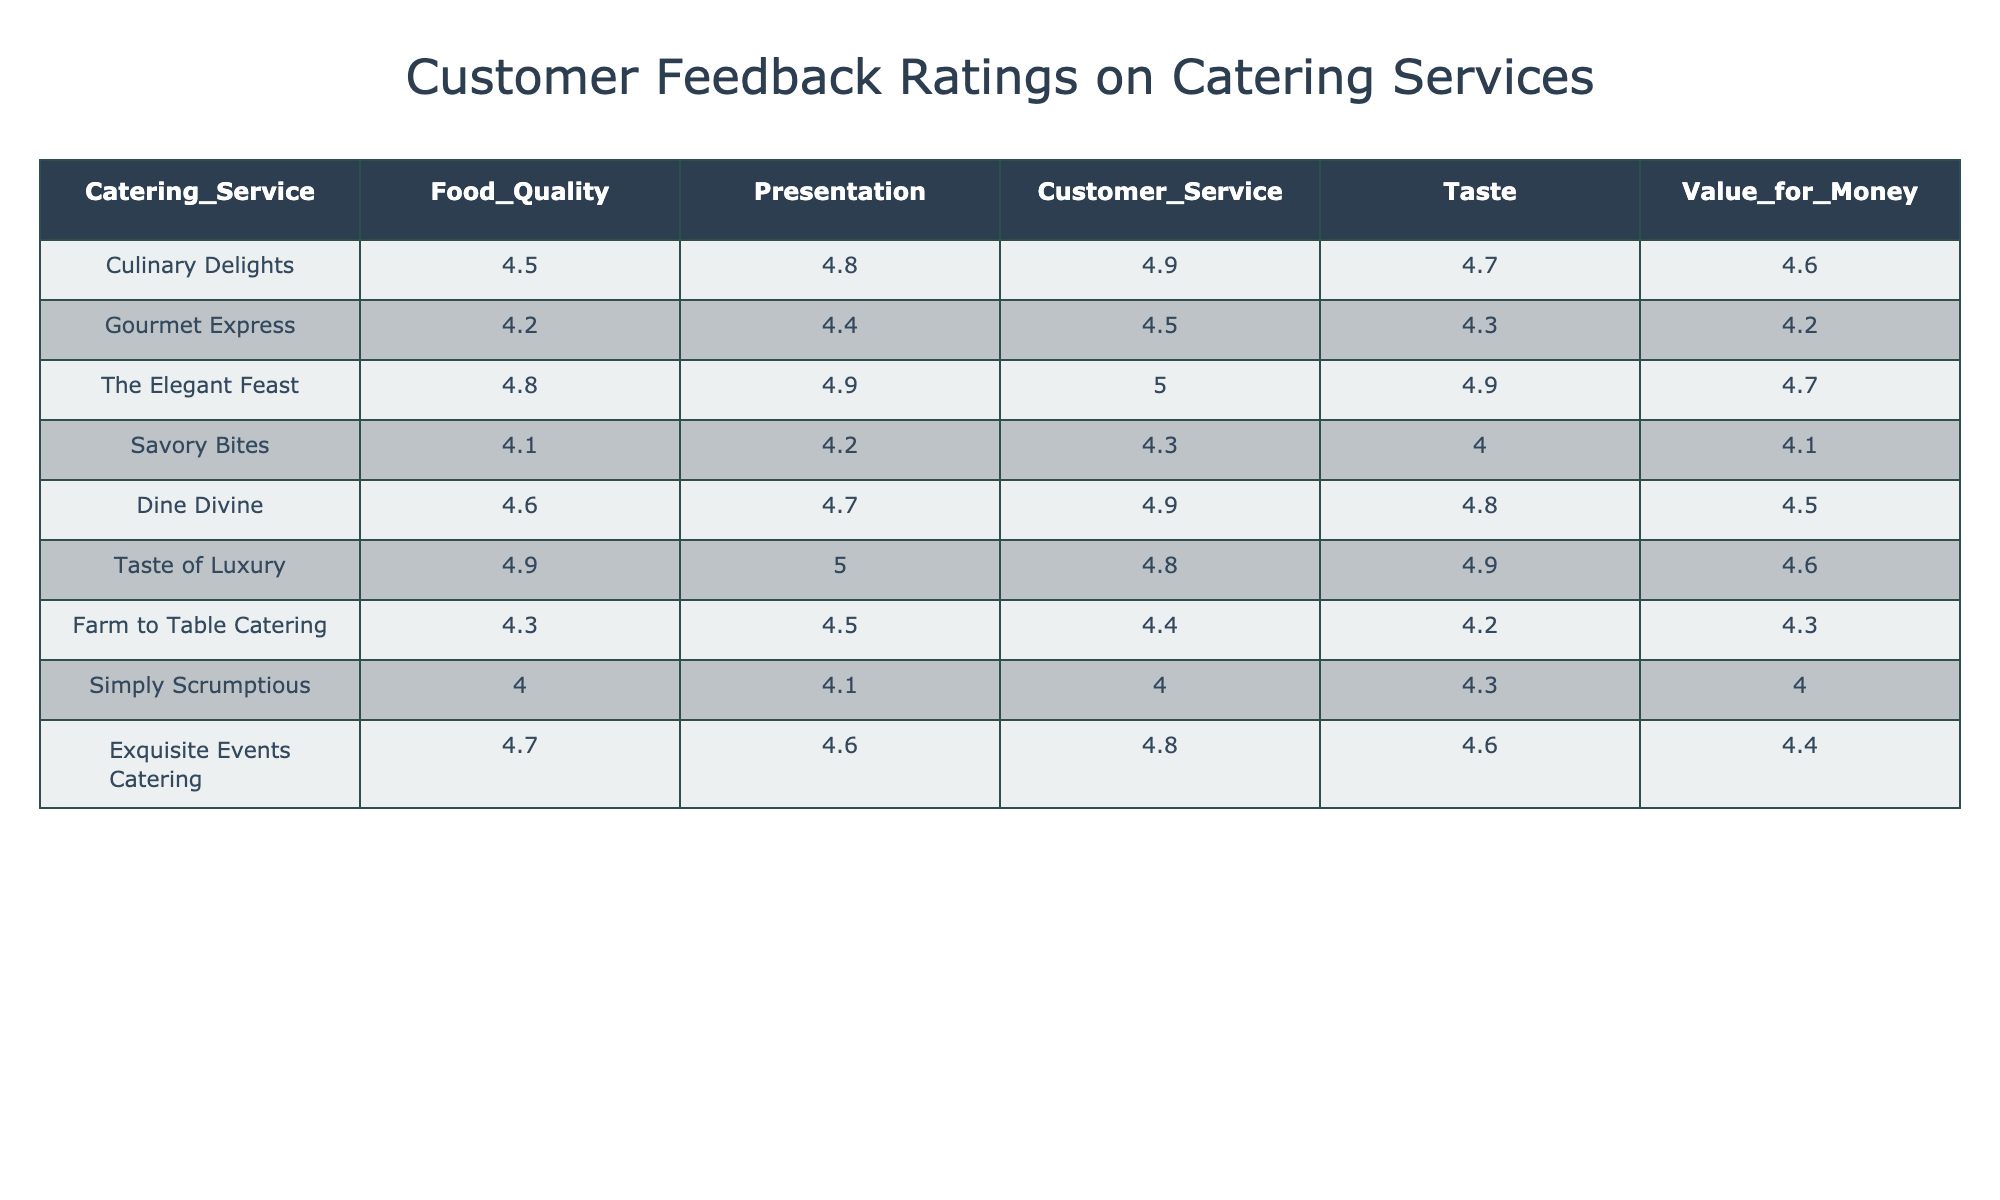What is the highest rating for customer service among the catering services? The ratings for customer service are listed under the "Customer_Service" column. The highest value in this column is 5.0, which corresponds to "The Elegant Feast".
Answer: 5.0 Which catering service has the lowest rating for food quality? The ratings for food quality can be found under the "Food_Quality" column. The lowest value in that column is 4.0, which corresponds to "Simply Scrumptious".
Answer: Simply Scrumptious What is the average rating for taste across all catering services? To find the average, sum all the ratings from the "Taste" column: (4.7 + 4.3 + 4.9 + 4.0 + 4.8 + 4.9 + 4.2 + 4.3 + 4.6) = 42.7. There are 9 ratings, so the average is 42.7 / 9 ≈ 4.74.
Answer: 4.74 Is the value for money rating greater than 4.5 for all services? The "Value_for_Money" column shows ratings for each service. By checking each rating, we see that "Savory Bites" and "Simply Scrumptious" have ratings below 4.5. Therefore, it is false that all services exceed 4.5.
Answer: No Which catering service has the best overall rating in all categories? The best overall rating can be determined by examining each service's ratings across all five categories (Food Quality, Presentation, Customer Service, Taste, Value for Money) and finding the average for each service. "The Elegant Feast" has the highest average rating of 4.82.
Answer: The Elegant Feast What are the two catering services with the closest ratings for presentation? The "Presentation" ratings show that "Gourmet Express" has a rating of 4.4 and "Savory Bites" has a rating of 4.2. The two closest ratings are 4.4 and 4.2.
Answer: Gourmet Express and Savory Bites Is Taste of Luxury rated higher for food quality than Dine Divine? Comparing the values in the "Food_Quality" column, "Taste of Luxury" has a rating of 4.9, while "Dine Divine" has a rating of 4.6. Therefore, it is true that Taste of Luxury is rated higher for food quality.
Answer: Yes What is the difference in rating between the highest and lowest for value for money? The highest value for money rating is 4.7 (The Elegant Feast), and the lowest is 4.0 (Simply Scrumptious). The difference is 4.7 - 4.0 = 0.7.
Answer: 0.7 